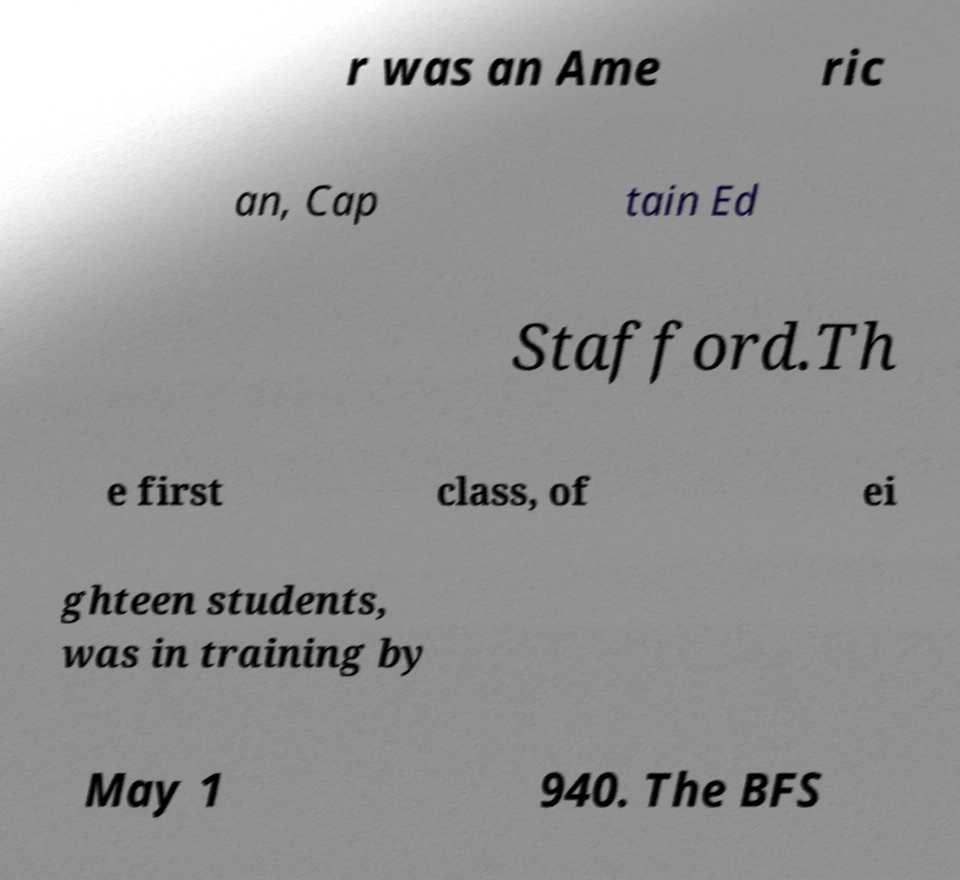There's text embedded in this image that I need extracted. Can you transcribe it verbatim? r was an Ame ric an, Cap tain Ed Stafford.Th e first class, of ei ghteen students, was in training by May 1 940. The BFS 